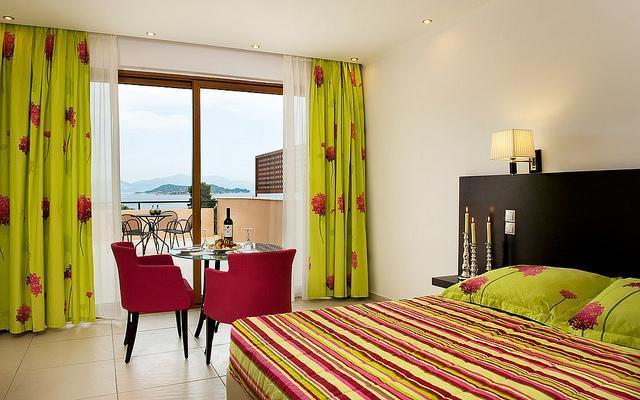How many chairs are there?
Give a very brief answer. 2. 